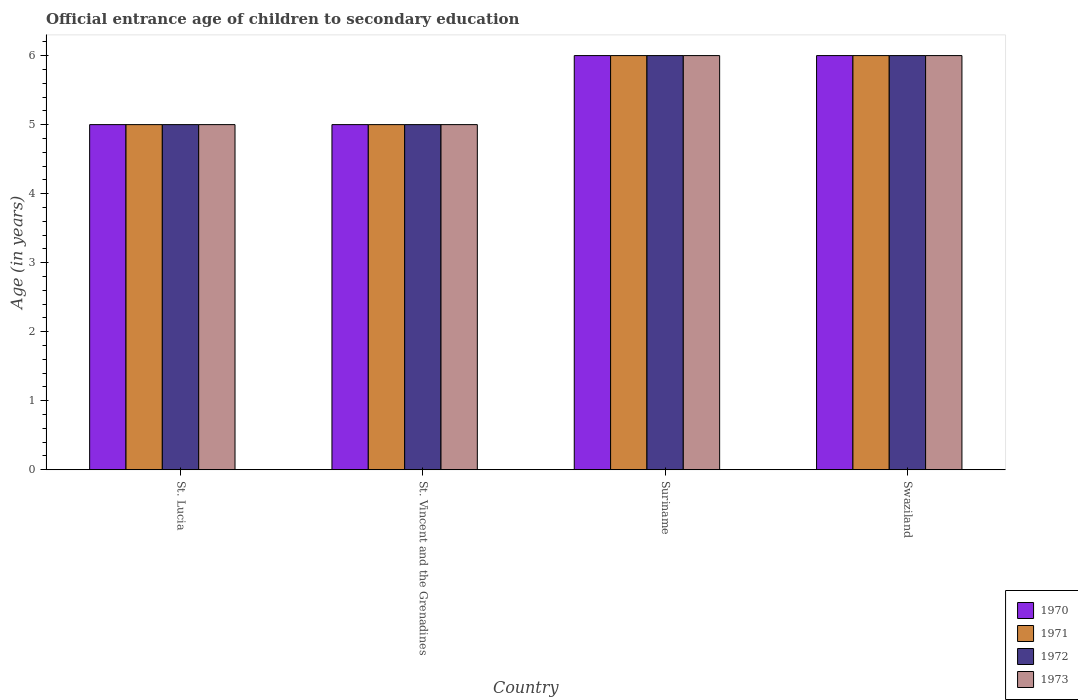How many groups of bars are there?
Keep it short and to the point. 4. Are the number of bars per tick equal to the number of legend labels?
Offer a very short reply. Yes. What is the label of the 2nd group of bars from the left?
Make the answer very short. St. Vincent and the Grenadines. What is the secondary school starting age of children in 1972 in Suriname?
Offer a terse response. 6. Across all countries, what is the minimum secondary school starting age of children in 1972?
Your answer should be compact. 5. In which country was the secondary school starting age of children in 1970 maximum?
Keep it short and to the point. Suriname. In which country was the secondary school starting age of children in 1973 minimum?
Make the answer very short. St. Lucia. What is the difference between the secondary school starting age of children in 1970 in St. Lucia and that in Suriname?
Provide a succinct answer. -1. What is the difference between the secondary school starting age of children in 1971 in St. Lucia and the secondary school starting age of children in 1970 in Swaziland?
Provide a succinct answer. -1. What is the average secondary school starting age of children in 1973 per country?
Keep it short and to the point. 5.5. What is the difference between the secondary school starting age of children of/in 1973 and secondary school starting age of children of/in 1970 in Suriname?
Offer a very short reply. 0. What is the ratio of the secondary school starting age of children in 1971 in St. Vincent and the Grenadines to that in Suriname?
Make the answer very short. 0.83. Is the secondary school starting age of children in 1972 in St. Lucia less than that in St. Vincent and the Grenadines?
Your response must be concise. No. Is the difference between the secondary school starting age of children in 1973 in St. Lucia and Swaziland greater than the difference between the secondary school starting age of children in 1970 in St. Lucia and Swaziland?
Ensure brevity in your answer.  No. What is the difference between the highest and the second highest secondary school starting age of children in 1970?
Offer a terse response. -1. What is the difference between the highest and the lowest secondary school starting age of children in 1973?
Give a very brief answer. 1. Is it the case that in every country, the sum of the secondary school starting age of children in 1970 and secondary school starting age of children in 1971 is greater than the sum of secondary school starting age of children in 1972 and secondary school starting age of children in 1973?
Offer a very short reply. No. What does the 4th bar from the left in St. Lucia represents?
Provide a short and direct response. 1973. What does the 2nd bar from the right in St. Lucia represents?
Offer a terse response. 1972. Is it the case that in every country, the sum of the secondary school starting age of children in 1973 and secondary school starting age of children in 1972 is greater than the secondary school starting age of children in 1970?
Provide a short and direct response. Yes. Are all the bars in the graph horizontal?
Offer a very short reply. No. Are the values on the major ticks of Y-axis written in scientific E-notation?
Provide a succinct answer. No. Does the graph contain grids?
Make the answer very short. No. How many legend labels are there?
Ensure brevity in your answer.  4. How are the legend labels stacked?
Provide a short and direct response. Vertical. What is the title of the graph?
Ensure brevity in your answer.  Official entrance age of children to secondary education. Does "1961" appear as one of the legend labels in the graph?
Your response must be concise. No. What is the label or title of the Y-axis?
Offer a terse response. Age (in years). What is the Age (in years) in 1972 in St. Lucia?
Provide a short and direct response. 5. What is the Age (in years) in 1973 in St. Lucia?
Give a very brief answer. 5. What is the Age (in years) in 1970 in St. Vincent and the Grenadines?
Give a very brief answer. 5. What is the Age (in years) in 1972 in St. Vincent and the Grenadines?
Ensure brevity in your answer.  5. What is the Age (in years) of 1972 in Suriname?
Your response must be concise. 6. What is the Age (in years) of 1972 in Swaziland?
Keep it short and to the point. 6. What is the Age (in years) of 1973 in Swaziland?
Your response must be concise. 6. Across all countries, what is the maximum Age (in years) of 1970?
Offer a terse response. 6. Across all countries, what is the maximum Age (in years) of 1971?
Keep it short and to the point. 6. Across all countries, what is the maximum Age (in years) of 1973?
Offer a very short reply. 6. Across all countries, what is the minimum Age (in years) of 1972?
Offer a terse response. 5. Across all countries, what is the minimum Age (in years) of 1973?
Your answer should be compact. 5. What is the total Age (in years) in 1971 in the graph?
Ensure brevity in your answer.  22. What is the total Age (in years) of 1972 in the graph?
Keep it short and to the point. 22. What is the difference between the Age (in years) in 1970 in St. Lucia and that in St. Vincent and the Grenadines?
Provide a succinct answer. 0. What is the difference between the Age (in years) in 1971 in St. Lucia and that in St. Vincent and the Grenadines?
Provide a succinct answer. 0. What is the difference between the Age (in years) in 1971 in St. Lucia and that in Suriname?
Offer a very short reply. -1. What is the difference between the Age (in years) of 1972 in St. Lucia and that in Suriname?
Offer a very short reply. -1. What is the difference between the Age (in years) in 1970 in St. Lucia and that in Swaziland?
Offer a terse response. -1. What is the difference between the Age (in years) of 1971 in St. Lucia and that in Swaziland?
Keep it short and to the point. -1. What is the difference between the Age (in years) of 1972 in St. Lucia and that in Swaziland?
Provide a short and direct response. -1. What is the difference between the Age (in years) in 1972 in St. Vincent and the Grenadines and that in Suriname?
Provide a succinct answer. -1. What is the difference between the Age (in years) in 1971 in St. Vincent and the Grenadines and that in Swaziland?
Provide a succinct answer. -1. What is the difference between the Age (in years) of 1972 in St. Vincent and the Grenadines and that in Swaziland?
Offer a terse response. -1. What is the difference between the Age (in years) of 1972 in Suriname and that in Swaziland?
Your answer should be very brief. 0. What is the difference between the Age (in years) in 1970 in St. Lucia and the Age (in years) in 1973 in St. Vincent and the Grenadines?
Provide a short and direct response. 0. What is the difference between the Age (in years) in 1972 in St. Lucia and the Age (in years) in 1973 in St. Vincent and the Grenadines?
Give a very brief answer. 0. What is the difference between the Age (in years) of 1970 in St. Lucia and the Age (in years) of 1971 in Suriname?
Offer a very short reply. -1. What is the difference between the Age (in years) of 1970 in St. Lucia and the Age (in years) of 1972 in Suriname?
Make the answer very short. -1. What is the difference between the Age (in years) in 1970 in St. Lucia and the Age (in years) in 1973 in Suriname?
Offer a very short reply. -1. What is the difference between the Age (in years) of 1970 in St. Lucia and the Age (in years) of 1971 in Swaziland?
Keep it short and to the point. -1. What is the difference between the Age (in years) of 1970 in St. Lucia and the Age (in years) of 1973 in Swaziland?
Your answer should be very brief. -1. What is the difference between the Age (in years) in 1972 in St. Lucia and the Age (in years) in 1973 in Swaziland?
Offer a terse response. -1. What is the difference between the Age (in years) in 1970 in St. Vincent and the Grenadines and the Age (in years) in 1971 in Suriname?
Your answer should be compact. -1. What is the difference between the Age (in years) in 1970 in St. Vincent and the Grenadines and the Age (in years) in 1972 in Suriname?
Your response must be concise. -1. What is the difference between the Age (in years) in 1971 in St. Vincent and the Grenadines and the Age (in years) in 1973 in Suriname?
Make the answer very short. -1. What is the difference between the Age (in years) of 1972 in St. Vincent and the Grenadines and the Age (in years) of 1973 in Suriname?
Provide a succinct answer. -1. What is the difference between the Age (in years) in 1970 in St. Vincent and the Grenadines and the Age (in years) in 1971 in Swaziland?
Ensure brevity in your answer.  -1. What is the difference between the Age (in years) in 1971 in St. Vincent and the Grenadines and the Age (in years) in 1972 in Swaziland?
Offer a very short reply. -1. What is the difference between the Age (in years) of 1972 in St. Vincent and the Grenadines and the Age (in years) of 1973 in Swaziland?
Your answer should be compact. -1. What is the difference between the Age (in years) in 1970 in Suriname and the Age (in years) in 1971 in Swaziland?
Give a very brief answer. 0. What is the difference between the Age (in years) of 1970 in Suriname and the Age (in years) of 1973 in Swaziland?
Make the answer very short. 0. What is the difference between the Age (in years) in 1971 in Suriname and the Age (in years) in 1973 in Swaziland?
Your answer should be very brief. 0. What is the average Age (in years) in 1971 per country?
Offer a very short reply. 5.5. What is the difference between the Age (in years) in 1970 and Age (in years) in 1972 in St. Lucia?
Ensure brevity in your answer.  0. What is the difference between the Age (in years) in 1970 and Age (in years) in 1973 in St. Lucia?
Offer a very short reply. 0. What is the difference between the Age (in years) of 1971 and Age (in years) of 1972 in St. Lucia?
Ensure brevity in your answer.  0. What is the difference between the Age (in years) of 1971 and Age (in years) of 1973 in St. Lucia?
Give a very brief answer. 0. What is the difference between the Age (in years) of 1971 and Age (in years) of 1973 in St. Vincent and the Grenadines?
Keep it short and to the point. 0. What is the difference between the Age (in years) in 1972 and Age (in years) in 1973 in St. Vincent and the Grenadines?
Provide a short and direct response. 0. What is the difference between the Age (in years) in 1970 and Age (in years) in 1971 in Suriname?
Provide a short and direct response. 0. What is the difference between the Age (in years) in 1970 and Age (in years) in 1972 in Suriname?
Keep it short and to the point. 0. What is the difference between the Age (in years) in 1971 and Age (in years) in 1972 in Suriname?
Your answer should be very brief. 0. What is the difference between the Age (in years) of 1970 and Age (in years) of 1971 in Swaziland?
Keep it short and to the point. 0. What is the difference between the Age (in years) in 1970 and Age (in years) in 1973 in Swaziland?
Your response must be concise. 0. What is the difference between the Age (in years) of 1971 and Age (in years) of 1973 in Swaziland?
Your answer should be very brief. 0. What is the difference between the Age (in years) in 1972 and Age (in years) in 1973 in Swaziland?
Your response must be concise. 0. What is the ratio of the Age (in years) of 1970 in St. Lucia to that in St. Vincent and the Grenadines?
Your answer should be compact. 1. What is the ratio of the Age (in years) in 1971 in St. Lucia to that in St. Vincent and the Grenadines?
Provide a short and direct response. 1. What is the ratio of the Age (in years) in 1972 in St. Lucia to that in St. Vincent and the Grenadines?
Ensure brevity in your answer.  1. What is the ratio of the Age (in years) of 1971 in St. Lucia to that in Suriname?
Ensure brevity in your answer.  0.83. What is the ratio of the Age (in years) of 1970 in St. Lucia to that in Swaziland?
Offer a terse response. 0.83. What is the ratio of the Age (in years) of 1972 in St. Lucia to that in Swaziland?
Your answer should be very brief. 0.83. What is the ratio of the Age (in years) in 1970 in St. Vincent and the Grenadines to that in Suriname?
Your answer should be compact. 0.83. What is the ratio of the Age (in years) in 1971 in St. Vincent and the Grenadines to that in Suriname?
Offer a very short reply. 0.83. What is the ratio of the Age (in years) in 1972 in St. Vincent and the Grenadines to that in Suriname?
Your response must be concise. 0.83. What is the ratio of the Age (in years) of 1973 in St. Vincent and the Grenadines to that in Suriname?
Provide a short and direct response. 0.83. What is the ratio of the Age (in years) of 1970 in St. Vincent and the Grenadines to that in Swaziland?
Your response must be concise. 0.83. What is the ratio of the Age (in years) of 1970 in Suriname to that in Swaziland?
Your answer should be compact. 1. What is the ratio of the Age (in years) of 1971 in Suriname to that in Swaziland?
Provide a short and direct response. 1. What is the ratio of the Age (in years) in 1973 in Suriname to that in Swaziland?
Your answer should be very brief. 1. What is the difference between the highest and the second highest Age (in years) of 1970?
Your answer should be very brief. 0. What is the difference between the highest and the second highest Age (in years) in 1971?
Ensure brevity in your answer.  0. What is the difference between the highest and the second highest Age (in years) in 1972?
Provide a succinct answer. 0. What is the difference between the highest and the lowest Age (in years) in 1970?
Offer a very short reply. 1. What is the difference between the highest and the lowest Age (in years) of 1971?
Your response must be concise. 1. What is the difference between the highest and the lowest Age (in years) in 1973?
Ensure brevity in your answer.  1. 